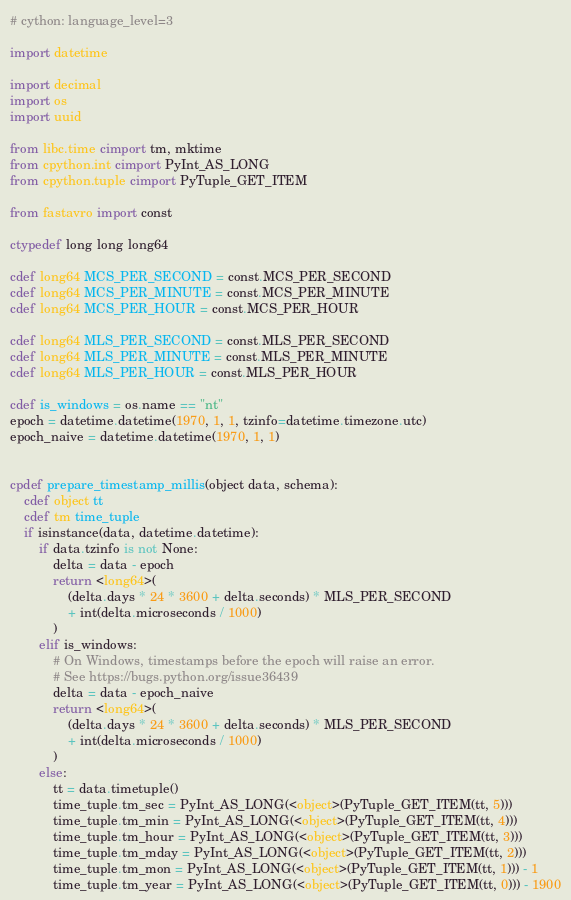<code> <loc_0><loc_0><loc_500><loc_500><_Cython_># cython: language_level=3

import datetime

import decimal
import os
import uuid

from libc.time cimport tm, mktime
from cpython.int cimport PyInt_AS_LONG
from cpython.tuple cimport PyTuple_GET_ITEM

from fastavro import const

ctypedef long long long64

cdef long64 MCS_PER_SECOND = const.MCS_PER_SECOND
cdef long64 MCS_PER_MINUTE = const.MCS_PER_MINUTE
cdef long64 MCS_PER_HOUR = const.MCS_PER_HOUR

cdef long64 MLS_PER_SECOND = const.MLS_PER_SECOND
cdef long64 MLS_PER_MINUTE = const.MLS_PER_MINUTE
cdef long64 MLS_PER_HOUR = const.MLS_PER_HOUR

cdef is_windows = os.name == "nt"
epoch = datetime.datetime(1970, 1, 1, tzinfo=datetime.timezone.utc)
epoch_naive = datetime.datetime(1970, 1, 1)


cpdef prepare_timestamp_millis(object data, schema):
    cdef object tt
    cdef tm time_tuple
    if isinstance(data, datetime.datetime):
        if data.tzinfo is not None:
            delta = data - epoch
            return <long64>(
                (delta.days * 24 * 3600 + delta.seconds) * MLS_PER_SECOND
                + int(delta.microseconds / 1000)
            )
        elif is_windows:
            # On Windows, timestamps before the epoch will raise an error.
            # See https://bugs.python.org/issue36439
            delta = data - epoch_naive
            return <long64>(
                (delta.days * 24 * 3600 + delta.seconds) * MLS_PER_SECOND
                + int(delta.microseconds / 1000)
            )
        else:
            tt = data.timetuple()
            time_tuple.tm_sec = PyInt_AS_LONG(<object>(PyTuple_GET_ITEM(tt, 5)))
            time_tuple.tm_min = PyInt_AS_LONG(<object>(PyTuple_GET_ITEM(tt, 4)))
            time_tuple.tm_hour = PyInt_AS_LONG(<object>(PyTuple_GET_ITEM(tt, 3)))
            time_tuple.tm_mday = PyInt_AS_LONG(<object>(PyTuple_GET_ITEM(tt, 2)))
            time_tuple.tm_mon = PyInt_AS_LONG(<object>(PyTuple_GET_ITEM(tt, 1))) - 1
            time_tuple.tm_year = PyInt_AS_LONG(<object>(PyTuple_GET_ITEM(tt, 0))) - 1900</code> 